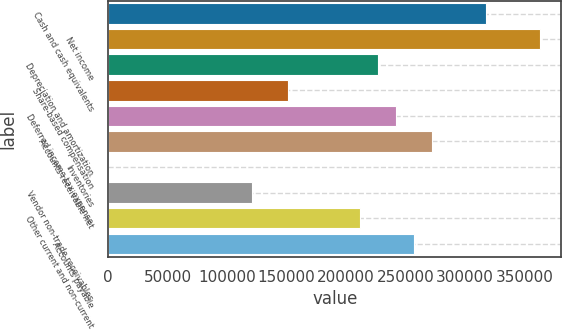Convert chart. <chart><loc_0><loc_0><loc_500><loc_500><bar_chart><fcel>Cash and cash equivalents<fcel>Net income<fcel>Depreciation and amortization<fcel>Share-based compensation<fcel>Deferred income tax expense<fcel>Accounts receivable net<fcel>Inventories<fcel>Vendor non-trade receivables<fcel>Other current and non-current<fcel>Accounts payable<nl><fcel>317571<fcel>362936<fcel>226840<fcel>151232<fcel>241962<fcel>272206<fcel>15<fcel>120989<fcel>211719<fcel>257084<nl></chart> 